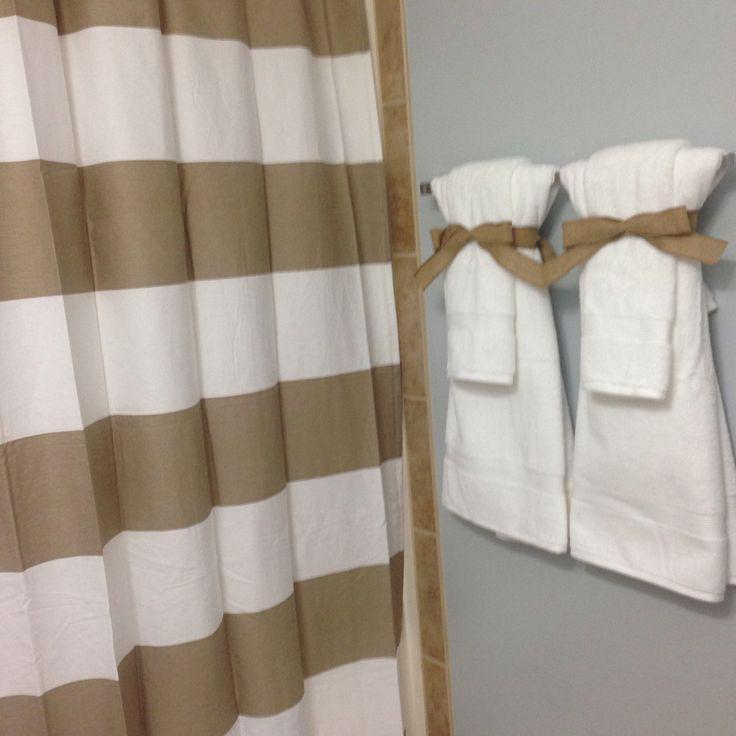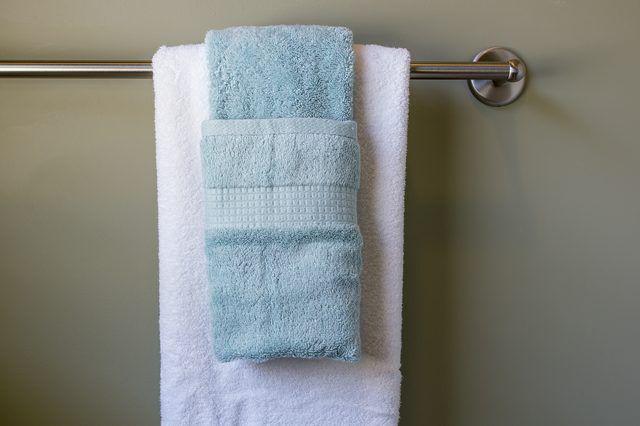The first image is the image on the left, the second image is the image on the right. For the images displayed, is the sentence "In one image, the small hand towel is light blue and the larger bath towel behind it is white." factually correct? Answer yes or no. Yes. The first image is the image on the left, the second image is the image on the right. Analyze the images presented: Is the assertion "In the left image, we see one white towel, on a rack." valid? Answer yes or no. No. 